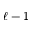<formula> <loc_0><loc_0><loc_500><loc_500>\ell - 1</formula> 